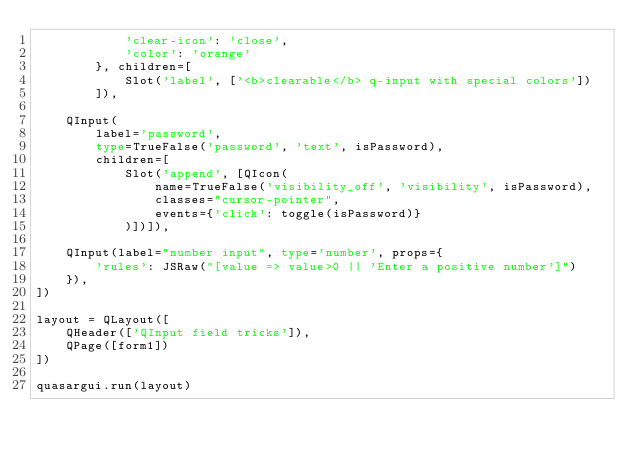Convert code to text. <code><loc_0><loc_0><loc_500><loc_500><_Python_>            'clear-icon': 'close',
            'color': 'orange'
        }, children=[
            Slot('label', ['<b>clearable</b> q-input with special colors'])
        ]),

    QInput(
        label='password',
        type=TrueFalse('password', 'text', isPassword),
        children=[
            Slot('append', [QIcon(
                name=TrueFalse('visibility_off', 'visibility', isPassword),
                classes="cursor-pointer",
                events={'click': toggle(isPassword)}
            )])]),

    QInput(label="number input", type='number', props={
        'rules': JSRaw("[value => value>0 || 'Enter a positive number']")
    }),
])

layout = QLayout([
    QHeader(['QInput field tricks']),
    QPage([form1])
])

quasargui.run(layout)
</code> 